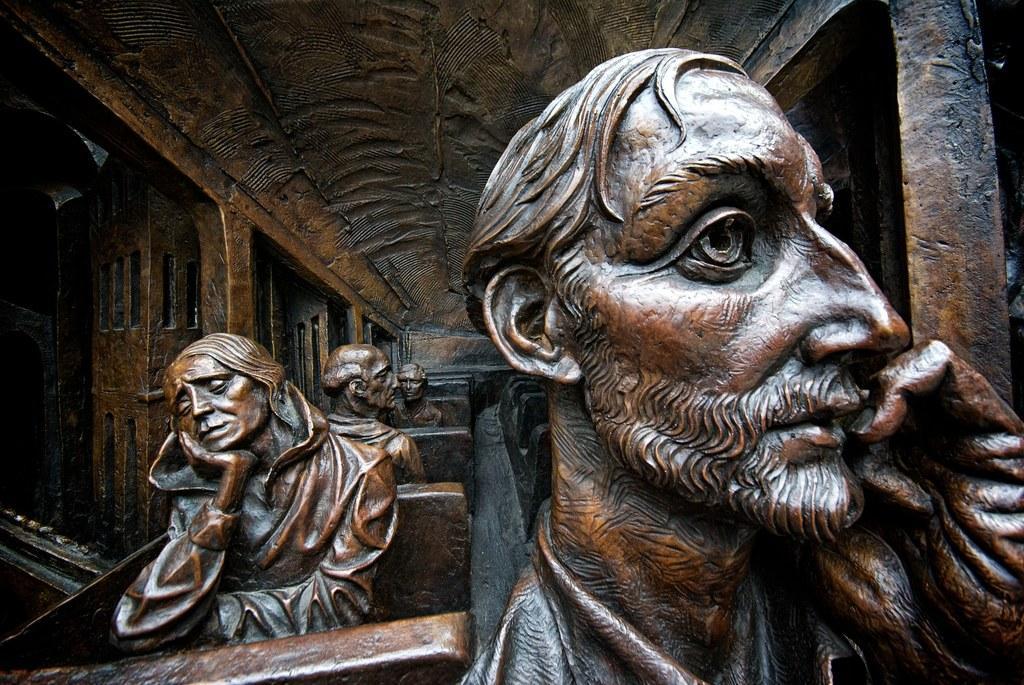Could you give a brief overview of what you see in this image? There are statues in sitting position on chairs of an architectural building. 